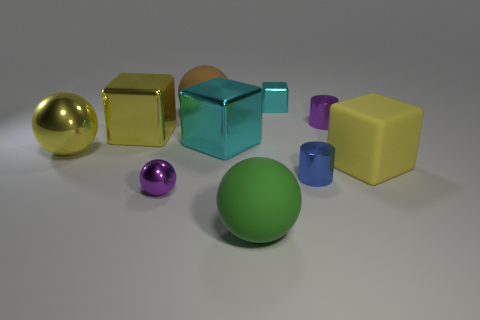Subtract 2 cubes. How many cubes are left? 2 Subtract all large cubes. How many cubes are left? 1 Subtract all brown cubes. Subtract all yellow cylinders. How many cubes are left? 4 Subtract all blocks. How many objects are left? 6 Subtract 0 gray spheres. How many objects are left? 10 Subtract all small rubber objects. Subtract all blue metallic cylinders. How many objects are left? 9 Add 2 shiny spheres. How many shiny spheres are left? 4 Add 8 big cyan shiny objects. How many big cyan shiny objects exist? 9 